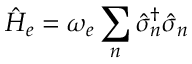Convert formula to latex. <formula><loc_0><loc_0><loc_500><loc_500>\hat { H } _ { e } = \omega _ { e } \sum _ { n } \hat { \sigma } _ { n } ^ { \dagger } \hat { \sigma } _ { n }</formula> 